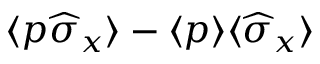<formula> <loc_0><loc_0><loc_500><loc_500>\langle p \widehat { \sigma } _ { x } \rangle - \langle p \rangle \langle \widehat { \sigma } _ { x } \rangle</formula> 